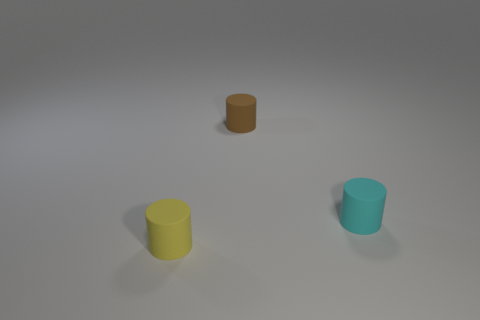Subtract all small yellow matte cylinders. How many cylinders are left? 2 Add 3 large brown shiny objects. How many objects exist? 6 Subtract all yellow cylinders. How many cylinders are left? 2 Subtract all blue cylinders. Subtract all green cubes. How many cylinders are left? 3 Subtract all cyan matte cylinders. Subtract all purple metal cylinders. How many objects are left? 2 Add 1 cylinders. How many cylinders are left? 4 Add 1 matte blocks. How many matte blocks exist? 1 Subtract 0 purple balls. How many objects are left? 3 